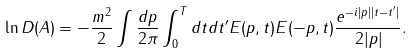<formula> <loc_0><loc_0><loc_500><loc_500>\ln D ( A ) = - \frac { m ^ { 2 } } 2 \int \frac { d p } { 2 \pi } \int _ { 0 } ^ { T } d t d t ^ { \prime } E ( p , t ) E ( - p , t ) \frac { e ^ { - i | p | | t - t ^ { \prime } | } } { 2 | p | } .</formula> 